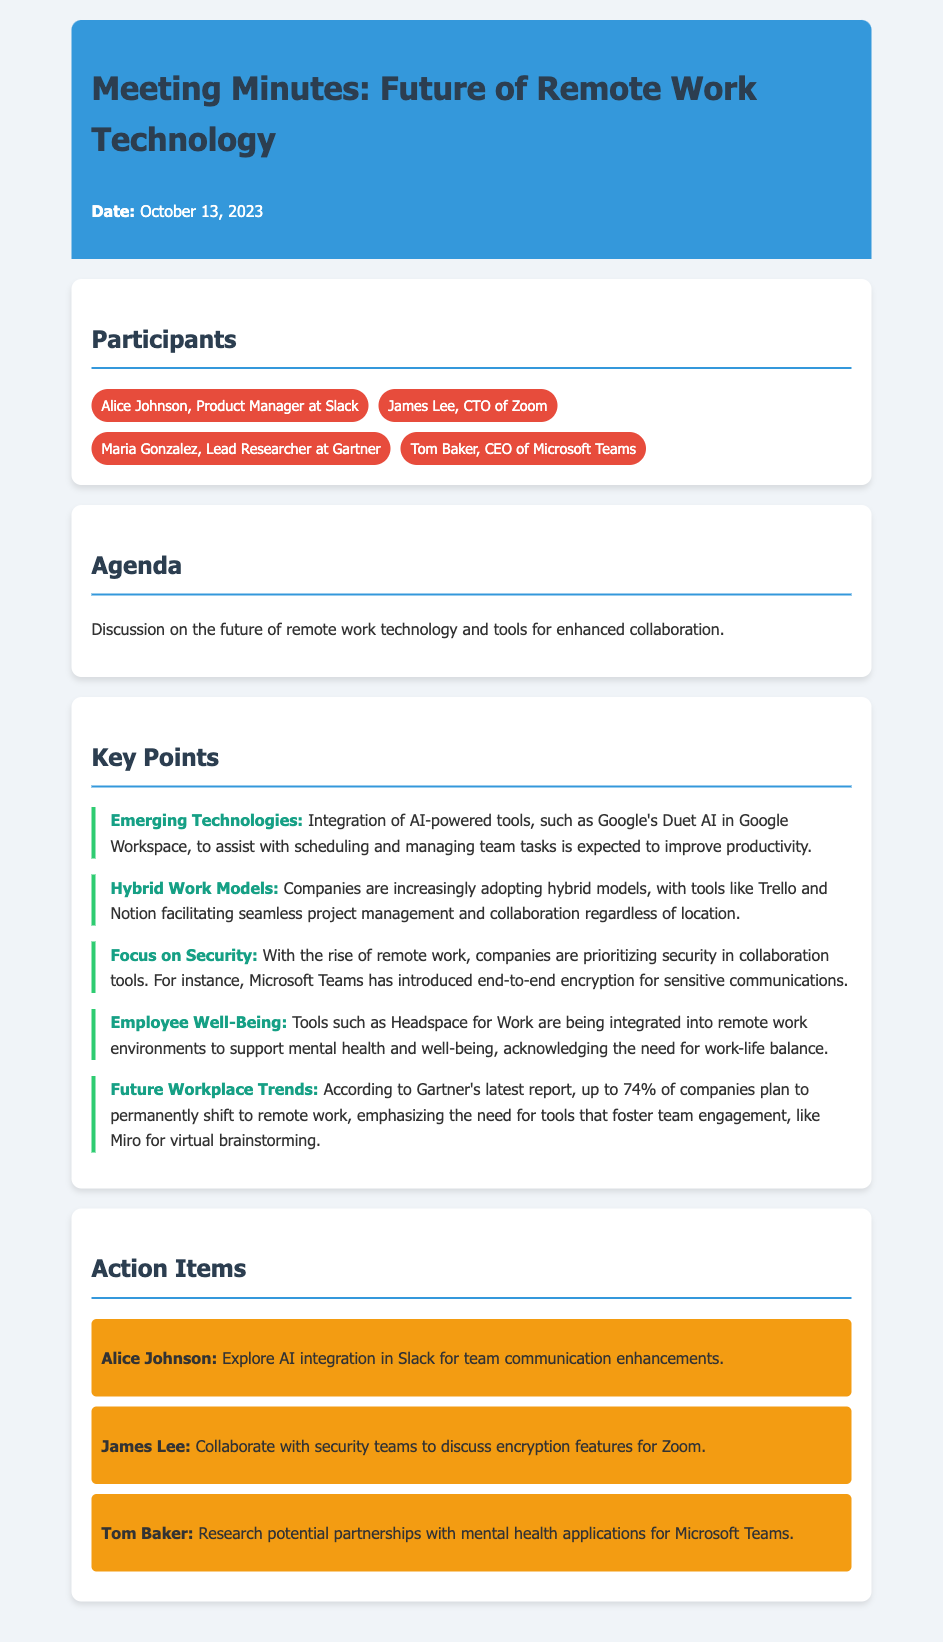What was the date of the meeting? The date of the meeting is stated in the header section of the document.
Answer: October 13, 2023 Who is the CTO of Zoom? The document lists participants and their titles, including the CTO of Zoom.
Answer: James Lee What tool is mentioned for assisting with scheduling in remote work? The document discusses AI-powered tools and mentions a specific tool for scheduling.
Answer: Google's Duet AI What percentage of companies plan to permanently shift to remote work according to Gartner's report? The document includes a statistic from a report by Gartner regarding the shift to remote work.
Answer: 74% Which application is suggested for mental health support in remote work? The document mentions a specific tool that focuses on employee well-being in remote work environments.
Answer: Headspace for Work What is Alice Johnson's action item? The action items section outlines specific tasks assigned to participants, including Alice Johnson's responsibility.
Answer: Explore AI integration in Slack for team communication enhancements 